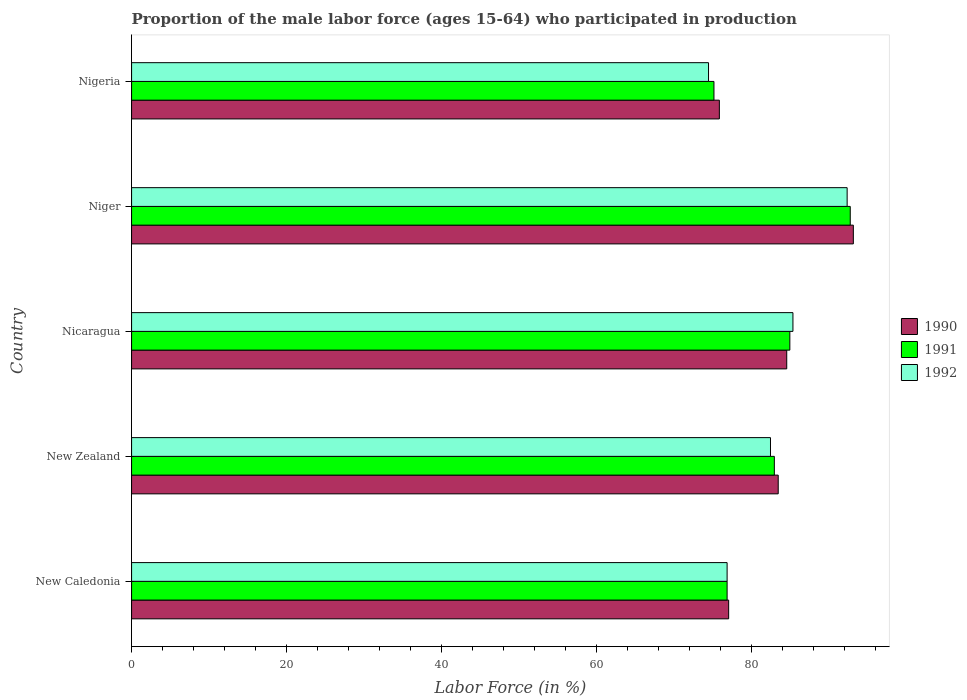How many different coloured bars are there?
Your answer should be very brief. 3. Are the number of bars on each tick of the Y-axis equal?
Your response must be concise. Yes. How many bars are there on the 2nd tick from the top?
Your answer should be compact. 3. What is the label of the 2nd group of bars from the top?
Your response must be concise. Niger. In how many cases, is the number of bars for a given country not equal to the number of legend labels?
Provide a succinct answer. 0. What is the proportion of the male labor force who participated in production in 1990 in Niger?
Offer a terse response. 93.2. Across all countries, what is the maximum proportion of the male labor force who participated in production in 1990?
Your answer should be very brief. 93.2. Across all countries, what is the minimum proportion of the male labor force who participated in production in 1991?
Ensure brevity in your answer.  75.2. In which country was the proportion of the male labor force who participated in production in 1990 maximum?
Your response must be concise. Niger. In which country was the proportion of the male labor force who participated in production in 1990 minimum?
Make the answer very short. Nigeria. What is the total proportion of the male labor force who participated in production in 1992 in the graph?
Your response must be concise. 411.7. What is the difference between the proportion of the male labor force who participated in production in 1992 in New Caledonia and the proportion of the male labor force who participated in production in 1991 in Niger?
Provide a short and direct response. -15.9. What is the average proportion of the male labor force who participated in production in 1992 per country?
Provide a short and direct response. 82.34. What is the difference between the proportion of the male labor force who participated in production in 1990 and proportion of the male labor force who participated in production in 1991 in Niger?
Keep it short and to the point. 0.4. What is the ratio of the proportion of the male labor force who participated in production in 1992 in New Zealand to that in Niger?
Offer a terse response. 0.89. Is the difference between the proportion of the male labor force who participated in production in 1990 in New Zealand and Nicaragua greater than the difference between the proportion of the male labor force who participated in production in 1991 in New Zealand and Nicaragua?
Provide a succinct answer. Yes. What is the difference between the highest and the second highest proportion of the male labor force who participated in production in 1992?
Ensure brevity in your answer.  7. What is the difference between the highest and the lowest proportion of the male labor force who participated in production in 1991?
Your response must be concise. 17.6. In how many countries, is the proportion of the male labor force who participated in production in 1990 greater than the average proportion of the male labor force who participated in production in 1990 taken over all countries?
Your answer should be compact. 3. How many bars are there?
Give a very brief answer. 15. Are all the bars in the graph horizontal?
Your response must be concise. Yes. How many countries are there in the graph?
Make the answer very short. 5. Does the graph contain any zero values?
Make the answer very short. No. Does the graph contain grids?
Give a very brief answer. No. Where does the legend appear in the graph?
Give a very brief answer. Center right. How many legend labels are there?
Your answer should be compact. 3. What is the title of the graph?
Give a very brief answer. Proportion of the male labor force (ages 15-64) who participated in production. Does "1977" appear as one of the legend labels in the graph?
Give a very brief answer. No. What is the Labor Force (in %) of 1990 in New Caledonia?
Provide a succinct answer. 77.1. What is the Labor Force (in %) of 1991 in New Caledonia?
Your answer should be compact. 76.9. What is the Labor Force (in %) of 1992 in New Caledonia?
Your response must be concise. 76.9. What is the Labor Force (in %) in 1990 in New Zealand?
Give a very brief answer. 83.5. What is the Labor Force (in %) in 1991 in New Zealand?
Your answer should be compact. 83. What is the Labor Force (in %) of 1992 in New Zealand?
Provide a succinct answer. 82.5. What is the Labor Force (in %) in 1990 in Nicaragua?
Your answer should be very brief. 84.6. What is the Labor Force (in %) in 1991 in Nicaragua?
Your answer should be compact. 85. What is the Labor Force (in %) of 1992 in Nicaragua?
Ensure brevity in your answer.  85.4. What is the Labor Force (in %) in 1990 in Niger?
Offer a very short reply. 93.2. What is the Labor Force (in %) of 1991 in Niger?
Ensure brevity in your answer.  92.8. What is the Labor Force (in %) in 1992 in Niger?
Provide a succinct answer. 92.4. What is the Labor Force (in %) of 1990 in Nigeria?
Your response must be concise. 75.9. What is the Labor Force (in %) of 1991 in Nigeria?
Keep it short and to the point. 75.2. What is the Labor Force (in %) in 1992 in Nigeria?
Give a very brief answer. 74.5. Across all countries, what is the maximum Labor Force (in %) of 1990?
Offer a very short reply. 93.2. Across all countries, what is the maximum Labor Force (in %) in 1991?
Offer a terse response. 92.8. Across all countries, what is the maximum Labor Force (in %) in 1992?
Provide a succinct answer. 92.4. Across all countries, what is the minimum Labor Force (in %) in 1990?
Your answer should be very brief. 75.9. Across all countries, what is the minimum Labor Force (in %) of 1991?
Your response must be concise. 75.2. Across all countries, what is the minimum Labor Force (in %) in 1992?
Keep it short and to the point. 74.5. What is the total Labor Force (in %) in 1990 in the graph?
Make the answer very short. 414.3. What is the total Labor Force (in %) in 1991 in the graph?
Provide a succinct answer. 412.9. What is the total Labor Force (in %) in 1992 in the graph?
Give a very brief answer. 411.7. What is the difference between the Labor Force (in %) in 1991 in New Caledonia and that in Nicaragua?
Provide a succinct answer. -8.1. What is the difference between the Labor Force (in %) in 1992 in New Caledonia and that in Nicaragua?
Your response must be concise. -8.5. What is the difference between the Labor Force (in %) of 1990 in New Caledonia and that in Niger?
Provide a succinct answer. -16.1. What is the difference between the Labor Force (in %) in 1991 in New Caledonia and that in Niger?
Offer a very short reply. -15.9. What is the difference between the Labor Force (in %) in 1992 in New Caledonia and that in Niger?
Make the answer very short. -15.5. What is the difference between the Labor Force (in %) in 1992 in New Caledonia and that in Nigeria?
Offer a very short reply. 2.4. What is the difference between the Labor Force (in %) of 1990 in New Zealand and that in Nicaragua?
Ensure brevity in your answer.  -1.1. What is the difference between the Labor Force (in %) of 1991 in New Zealand and that in Nicaragua?
Keep it short and to the point. -2. What is the difference between the Labor Force (in %) in 1992 in New Zealand and that in Nicaragua?
Offer a terse response. -2.9. What is the difference between the Labor Force (in %) in 1990 in New Zealand and that in Niger?
Your answer should be compact. -9.7. What is the difference between the Labor Force (in %) in 1991 in New Zealand and that in Niger?
Your response must be concise. -9.8. What is the difference between the Labor Force (in %) in 1990 in New Zealand and that in Nigeria?
Make the answer very short. 7.6. What is the difference between the Labor Force (in %) in 1991 in New Zealand and that in Nigeria?
Provide a succinct answer. 7.8. What is the difference between the Labor Force (in %) of 1992 in New Zealand and that in Nigeria?
Keep it short and to the point. 8. What is the difference between the Labor Force (in %) of 1991 in Nicaragua and that in Niger?
Offer a terse response. -7.8. What is the difference between the Labor Force (in %) of 1990 in Nicaragua and that in Nigeria?
Give a very brief answer. 8.7. What is the difference between the Labor Force (in %) in 1991 in Nicaragua and that in Nigeria?
Provide a succinct answer. 9.8. What is the difference between the Labor Force (in %) in 1992 in Nicaragua and that in Nigeria?
Your answer should be very brief. 10.9. What is the difference between the Labor Force (in %) in 1991 in Niger and that in Nigeria?
Your response must be concise. 17.6. What is the difference between the Labor Force (in %) in 1991 in New Caledonia and the Labor Force (in %) in 1992 in New Zealand?
Give a very brief answer. -5.6. What is the difference between the Labor Force (in %) of 1990 in New Caledonia and the Labor Force (in %) of 1991 in Nicaragua?
Provide a succinct answer. -7.9. What is the difference between the Labor Force (in %) in 1990 in New Caledonia and the Labor Force (in %) in 1992 in Nicaragua?
Offer a very short reply. -8.3. What is the difference between the Labor Force (in %) in 1990 in New Caledonia and the Labor Force (in %) in 1991 in Niger?
Your answer should be compact. -15.7. What is the difference between the Labor Force (in %) of 1990 in New Caledonia and the Labor Force (in %) of 1992 in Niger?
Your response must be concise. -15.3. What is the difference between the Labor Force (in %) of 1991 in New Caledonia and the Labor Force (in %) of 1992 in Niger?
Offer a very short reply. -15.5. What is the difference between the Labor Force (in %) in 1991 in New Caledonia and the Labor Force (in %) in 1992 in Nigeria?
Your answer should be compact. 2.4. What is the difference between the Labor Force (in %) in 1990 in New Zealand and the Labor Force (in %) in 1992 in Nicaragua?
Offer a terse response. -1.9. What is the difference between the Labor Force (in %) in 1990 in New Zealand and the Labor Force (in %) in 1991 in Niger?
Your answer should be very brief. -9.3. What is the difference between the Labor Force (in %) in 1990 in New Zealand and the Labor Force (in %) in 1992 in Niger?
Ensure brevity in your answer.  -8.9. What is the difference between the Labor Force (in %) of 1991 in New Zealand and the Labor Force (in %) of 1992 in Niger?
Your answer should be compact. -9.4. What is the difference between the Labor Force (in %) in 1990 in New Zealand and the Labor Force (in %) in 1991 in Nigeria?
Offer a very short reply. 8.3. What is the difference between the Labor Force (in %) in 1991 in New Zealand and the Labor Force (in %) in 1992 in Nigeria?
Keep it short and to the point. 8.5. What is the difference between the Labor Force (in %) of 1990 in Niger and the Labor Force (in %) of 1991 in Nigeria?
Give a very brief answer. 18. What is the difference between the Labor Force (in %) of 1990 in Niger and the Labor Force (in %) of 1992 in Nigeria?
Make the answer very short. 18.7. What is the average Labor Force (in %) in 1990 per country?
Keep it short and to the point. 82.86. What is the average Labor Force (in %) of 1991 per country?
Offer a very short reply. 82.58. What is the average Labor Force (in %) of 1992 per country?
Make the answer very short. 82.34. What is the difference between the Labor Force (in %) in 1990 and Labor Force (in %) in 1991 in New Caledonia?
Make the answer very short. 0.2. What is the difference between the Labor Force (in %) in 1990 and Labor Force (in %) in 1992 in New Caledonia?
Give a very brief answer. 0.2. What is the difference between the Labor Force (in %) in 1991 and Labor Force (in %) in 1992 in New Caledonia?
Your answer should be compact. 0. What is the difference between the Labor Force (in %) of 1990 and Labor Force (in %) of 1992 in New Zealand?
Keep it short and to the point. 1. What is the difference between the Labor Force (in %) in 1990 and Labor Force (in %) in 1991 in Nicaragua?
Offer a very short reply. -0.4. What is the difference between the Labor Force (in %) in 1990 and Labor Force (in %) in 1992 in Nicaragua?
Your answer should be very brief. -0.8. What is the difference between the Labor Force (in %) in 1991 and Labor Force (in %) in 1992 in Niger?
Provide a short and direct response. 0.4. What is the difference between the Labor Force (in %) in 1990 and Labor Force (in %) in 1991 in Nigeria?
Your answer should be very brief. 0.7. What is the difference between the Labor Force (in %) of 1990 and Labor Force (in %) of 1992 in Nigeria?
Offer a very short reply. 1.4. What is the difference between the Labor Force (in %) in 1991 and Labor Force (in %) in 1992 in Nigeria?
Offer a very short reply. 0.7. What is the ratio of the Labor Force (in %) of 1990 in New Caledonia to that in New Zealand?
Your answer should be compact. 0.92. What is the ratio of the Labor Force (in %) in 1991 in New Caledonia to that in New Zealand?
Give a very brief answer. 0.93. What is the ratio of the Labor Force (in %) in 1992 in New Caledonia to that in New Zealand?
Provide a short and direct response. 0.93. What is the ratio of the Labor Force (in %) of 1990 in New Caledonia to that in Nicaragua?
Offer a terse response. 0.91. What is the ratio of the Labor Force (in %) of 1991 in New Caledonia to that in Nicaragua?
Keep it short and to the point. 0.9. What is the ratio of the Labor Force (in %) of 1992 in New Caledonia to that in Nicaragua?
Offer a terse response. 0.9. What is the ratio of the Labor Force (in %) in 1990 in New Caledonia to that in Niger?
Keep it short and to the point. 0.83. What is the ratio of the Labor Force (in %) in 1991 in New Caledonia to that in Niger?
Give a very brief answer. 0.83. What is the ratio of the Labor Force (in %) in 1992 in New Caledonia to that in Niger?
Your response must be concise. 0.83. What is the ratio of the Labor Force (in %) of 1990 in New Caledonia to that in Nigeria?
Your answer should be very brief. 1.02. What is the ratio of the Labor Force (in %) of 1991 in New Caledonia to that in Nigeria?
Your response must be concise. 1.02. What is the ratio of the Labor Force (in %) in 1992 in New Caledonia to that in Nigeria?
Your response must be concise. 1.03. What is the ratio of the Labor Force (in %) of 1991 in New Zealand to that in Nicaragua?
Your response must be concise. 0.98. What is the ratio of the Labor Force (in %) of 1990 in New Zealand to that in Niger?
Offer a terse response. 0.9. What is the ratio of the Labor Force (in %) in 1991 in New Zealand to that in Niger?
Offer a terse response. 0.89. What is the ratio of the Labor Force (in %) of 1992 in New Zealand to that in Niger?
Offer a terse response. 0.89. What is the ratio of the Labor Force (in %) of 1990 in New Zealand to that in Nigeria?
Ensure brevity in your answer.  1.1. What is the ratio of the Labor Force (in %) of 1991 in New Zealand to that in Nigeria?
Offer a terse response. 1.1. What is the ratio of the Labor Force (in %) in 1992 in New Zealand to that in Nigeria?
Offer a very short reply. 1.11. What is the ratio of the Labor Force (in %) in 1990 in Nicaragua to that in Niger?
Provide a succinct answer. 0.91. What is the ratio of the Labor Force (in %) in 1991 in Nicaragua to that in Niger?
Your answer should be very brief. 0.92. What is the ratio of the Labor Force (in %) in 1992 in Nicaragua to that in Niger?
Offer a terse response. 0.92. What is the ratio of the Labor Force (in %) in 1990 in Nicaragua to that in Nigeria?
Your answer should be very brief. 1.11. What is the ratio of the Labor Force (in %) in 1991 in Nicaragua to that in Nigeria?
Provide a short and direct response. 1.13. What is the ratio of the Labor Force (in %) in 1992 in Nicaragua to that in Nigeria?
Provide a short and direct response. 1.15. What is the ratio of the Labor Force (in %) in 1990 in Niger to that in Nigeria?
Give a very brief answer. 1.23. What is the ratio of the Labor Force (in %) of 1991 in Niger to that in Nigeria?
Offer a terse response. 1.23. What is the ratio of the Labor Force (in %) of 1992 in Niger to that in Nigeria?
Offer a terse response. 1.24. What is the difference between the highest and the second highest Labor Force (in %) of 1990?
Give a very brief answer. 8.6. What is the difference between the highest and the second highest Labor Force (in %) in 1991?
Ensure brevity in your answer.  7.8. What is the difference between the highest and the lowest Labor Force (in %) of 1990?
Your answer should be very brief. 17.3. What is the difference between the highest and the lowest Labor Force (in %) in 1991?
Keep it short and to the point. 17.6. What is the difference between the highest and the lowest Labor Force (in %) in 1992?
Your response must be concise. 17.9. 